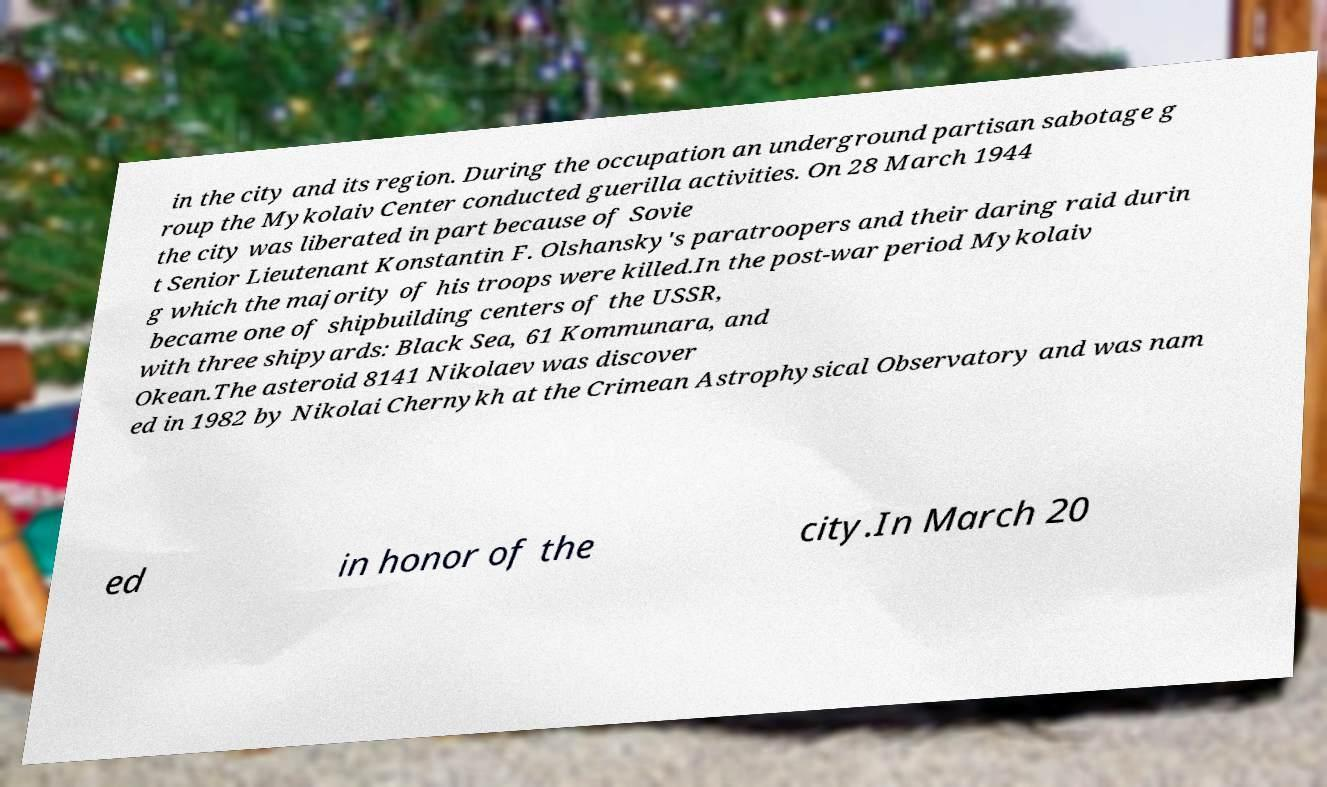There's text embedded in this image that I need extracted. Can you transcribe it verbatim? in the city and its region. During the occupation an underground partisan sabotage g roup the Mykolaiv Center conducted guerilla activities. On 28 March 1944 the city was liberated in part because of Sovie t Senior Lieutenant Konstantin F. Olshansky's paratroopers and their daring raid durin g which the majority of his troops were killed.In the post-war period Mykolaiv became one of shipbuilding centers of the USSR, with three shipyards: Black Sea, 61 Kommunara, and Okean.The asteroid 8141 Nikolaev was discover ed in 1982 by Nikolai Chernykh at the Crimean Astrophysical Observatory and was nam ed in honor of the city.In March 20 